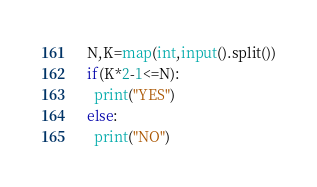Convert code to text. <code><loc_0><loc_0><loc_500><loc_500><_Python_>N,K=map(int,input().split())
if(K*2-1<=N):
  print("YES")
else:
  print("NO")</code> 